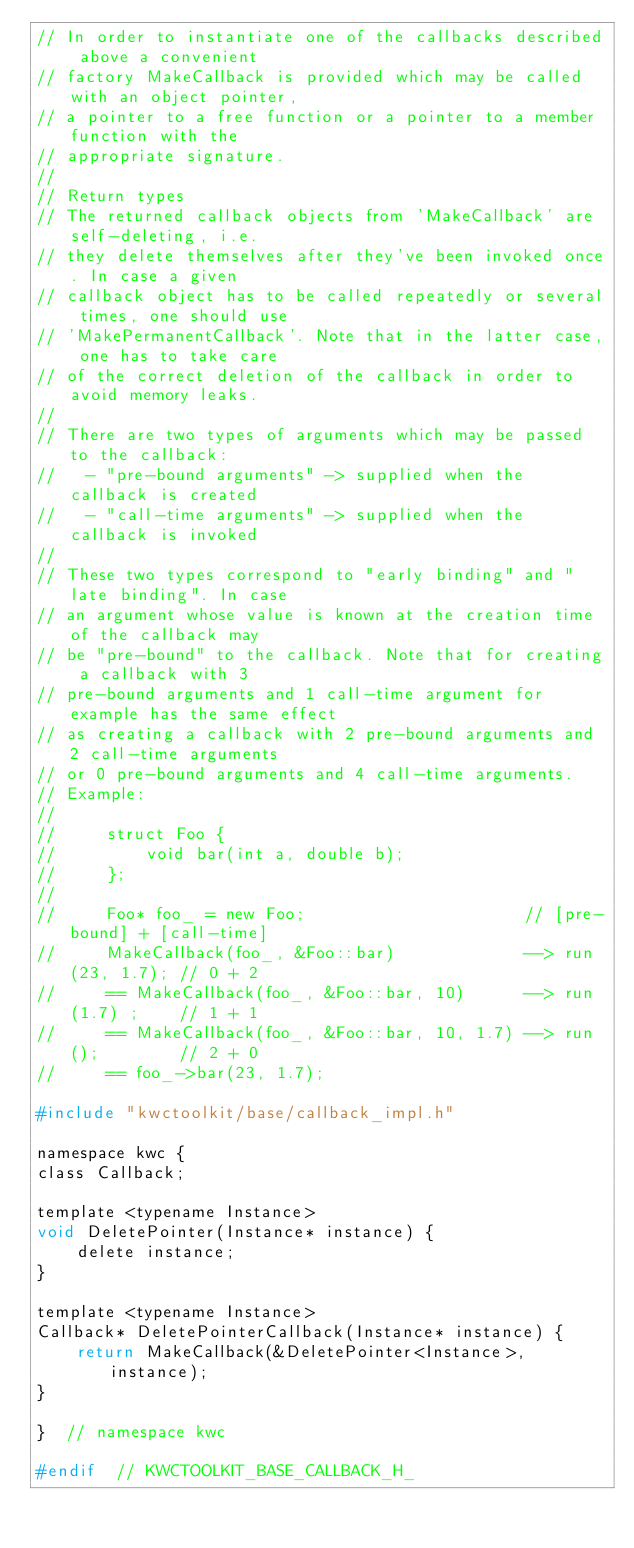Convert code to text. <code><loc_0><loc_0><loc_500><loc_500><_C_>// In order to instantiate one of the callbacks described above a convenient
// factory MakeCallback is provided which may be called with an object pointer,
// a pointer to a free function or a pointer to a member function with the
// appropriate signature.
//
// Return types
// The returned callback objects from 'MakeCallback' are self-deleting, i.e.
// they delete themselves after they've been invoked once. In case a given
// callback object has to be called repeatedly or several times, one should use
// 'MakePermanentCallback'. Note that in the latter case, one has to take care
// of the correct deletion of the callback in order to avoid memory leaks.
//
// There are two types of arguments which may be passed to the callback:
//   - "pre-bound arguments" -> supplied when the callback is created
//   - "call-time arguments" -> supplied when the callback is invoked
//
// These two types correspond to "early binding" and "late binding". In case
// an argument whose value is known at the creation time of the callback may
// be "pre-bound" to the callback. Note that for creating a callback with 3
// pre-bound arguments and 1 call-time argument for example has the same effect
// as creating a callback with 2 pre-bound arguments and 2 call-time arguments
// or 0 pre-bound arguments and 4 call-time arguments.
// Example:
//
//     struct Foo {
//         void bar(int a, double b);
//     };
//
//     Foo* foo_ = new Foo;                      // [pre-bound] + [call-time]
//     MakeCallback(foo_, &Foo::bar)             --> run(23, 1.7); // 0 + 2
//     == MakeCallback(foo_, &Foo::bar, 10)      --> run(1.7) ;    // 1 + 1
//     == MakeCallback(foo_, &Foo::bar, 10, 1.7) --> run();        // 2 + 0
//     == foo_->bar(23, 1.7);

#include "kwctoolkit/base/callback_impl.h"

namespace kwc {
class Callback;

template <typename Instance>
void DeletePointer(Instance* instance) {
    delete instance;
}

template <typename Instance>
Callback* DeletePointerCallback(Instance* instance) {
    return MakeCallback(&DeletePointer<Instance>, instance);
}

}  // namespace kwc

#endif  // KWCTOOLKIT_BASE_CALLBACK_H_
</code> 